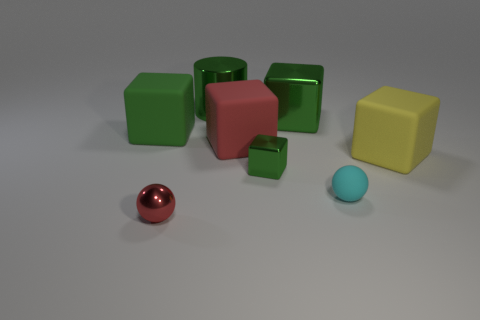Subtract all cyan balls. How many green blocks are left? 3 Subtract all red cubes. How many cubes are left? 4 Subtract all green rubber blocks. How many blocks are left? 4 Add 2 blue rubber cylinders. How many objects exist? 10 Subtract all brown blocks. Subtract all brown spheres. How many blocks are left? 5 Subtract all cylinders. How many objects are left? 7 Subtract 0 blue spheres. How many objects are left? 8 Subtract all big shiny objects. Subtract all large green blocks. How many objects are left? 4 Add 2 tiny green things. How many tiny green things are left? 3 Add 2 big rubber objects. How many big rubber objects exist? 5 